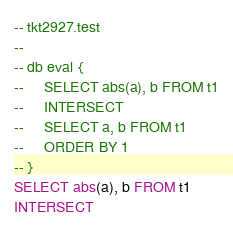Convert code to text. <code><loc_0><loc_0><loc_500><loc_500><_SQL_>-- tkt2927.test
-- 
-- db eval {
--     SELECT abs(a), b FROM t1
--     INTERSECT
--     SELECT a, b FROM t1
--     ORDER BY 1
-- }
SELECT abs(a), b FROM t1
INTERSECT</code> 